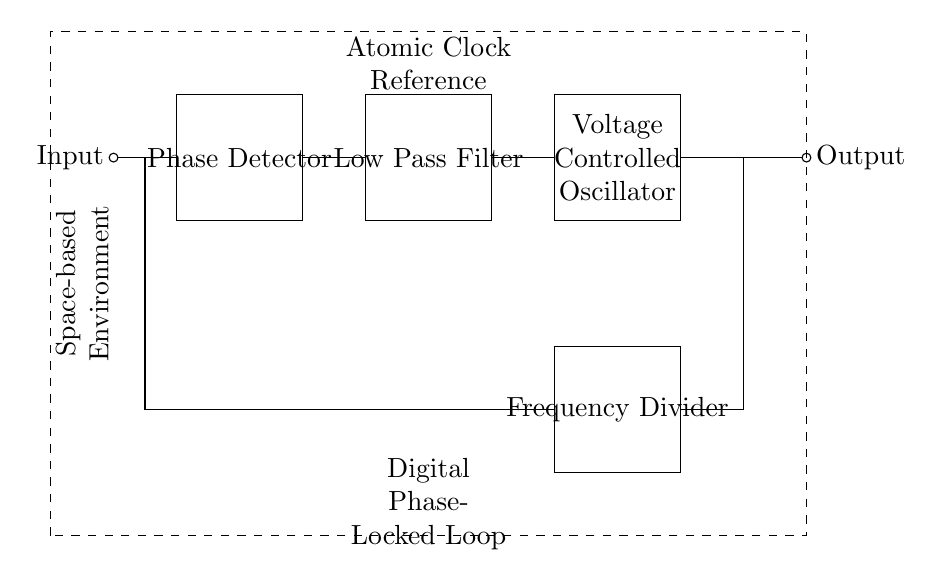What is the first component in the circuit? The first component is the Phase Detector, which is drawn on the left side of the circuit diagram.
Answer: Phase Detector What does the dashed rectangle represent? The dashed rectangle encompasses the entire digital phase-locked loop circuit, indicating a specific functional block. In this case, it highlights the entire atomic clock reference system including all components.
Answer: Atomic Clock Reference How many major functional blocks are there in the diagram? There are four major functional blocks labeled clearly in the schematic: the Phase Detector, Low Pass Filter, Voltage Controlled Oscillator, and Frequency Divider.
Answer: Four What is the output of the circuit connected to? The output is connected to a node which is indicated as the Output, showing that it leads to further circuitry or a measurement point in the system.
Answer: Output What role does the Voltage Controlled Oscillator play in the circuit? The Voltage Controlled Oscillator is responsible for providing a frequency output that can be adjusted based on the input voltage, crucial for maintaining synchronization in phase-locked loop operations.
Answer: Frequency Adjustment What type of environment is the circuit designed for? The circuit is specifically designed for a space-based environment, as indicated by the label on the left side of the schematic diagram.
Answer: Space-based Environment How does the Frequency Divider interact with the other components? The Frequency Divider divides the frequency output from the Voltage Controlled Oscillator and sends it back into the Phase Detector for comparison with the input signal, aiding in achieving synchronization.
Answer: Frequency Division 